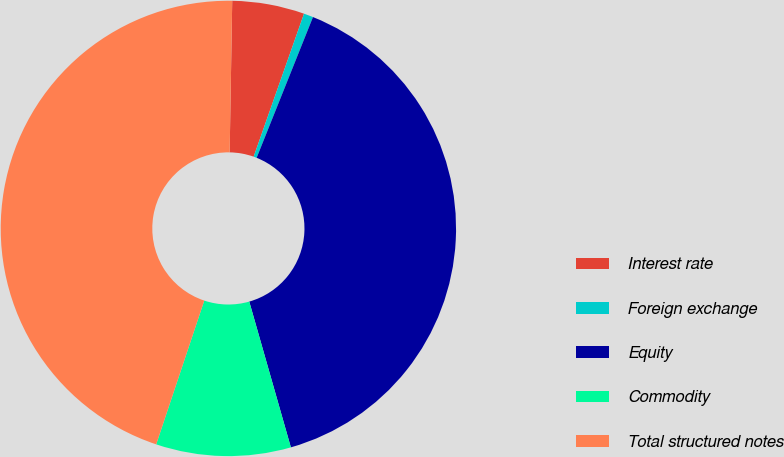Convert chart to OTSL. <chart><loc_0><loc_0><loc_500><loc_500><pie_chart><fcel>Interest rate<fcel>Foreign exchange<fcel>Equity<fcel>Commodity<fcel>Total structured notes<nl><fcel>5.12%<fcel>0.67%<fcel>39.51%<fcel>9.56%<fcel>45.13%<nl></chart> 